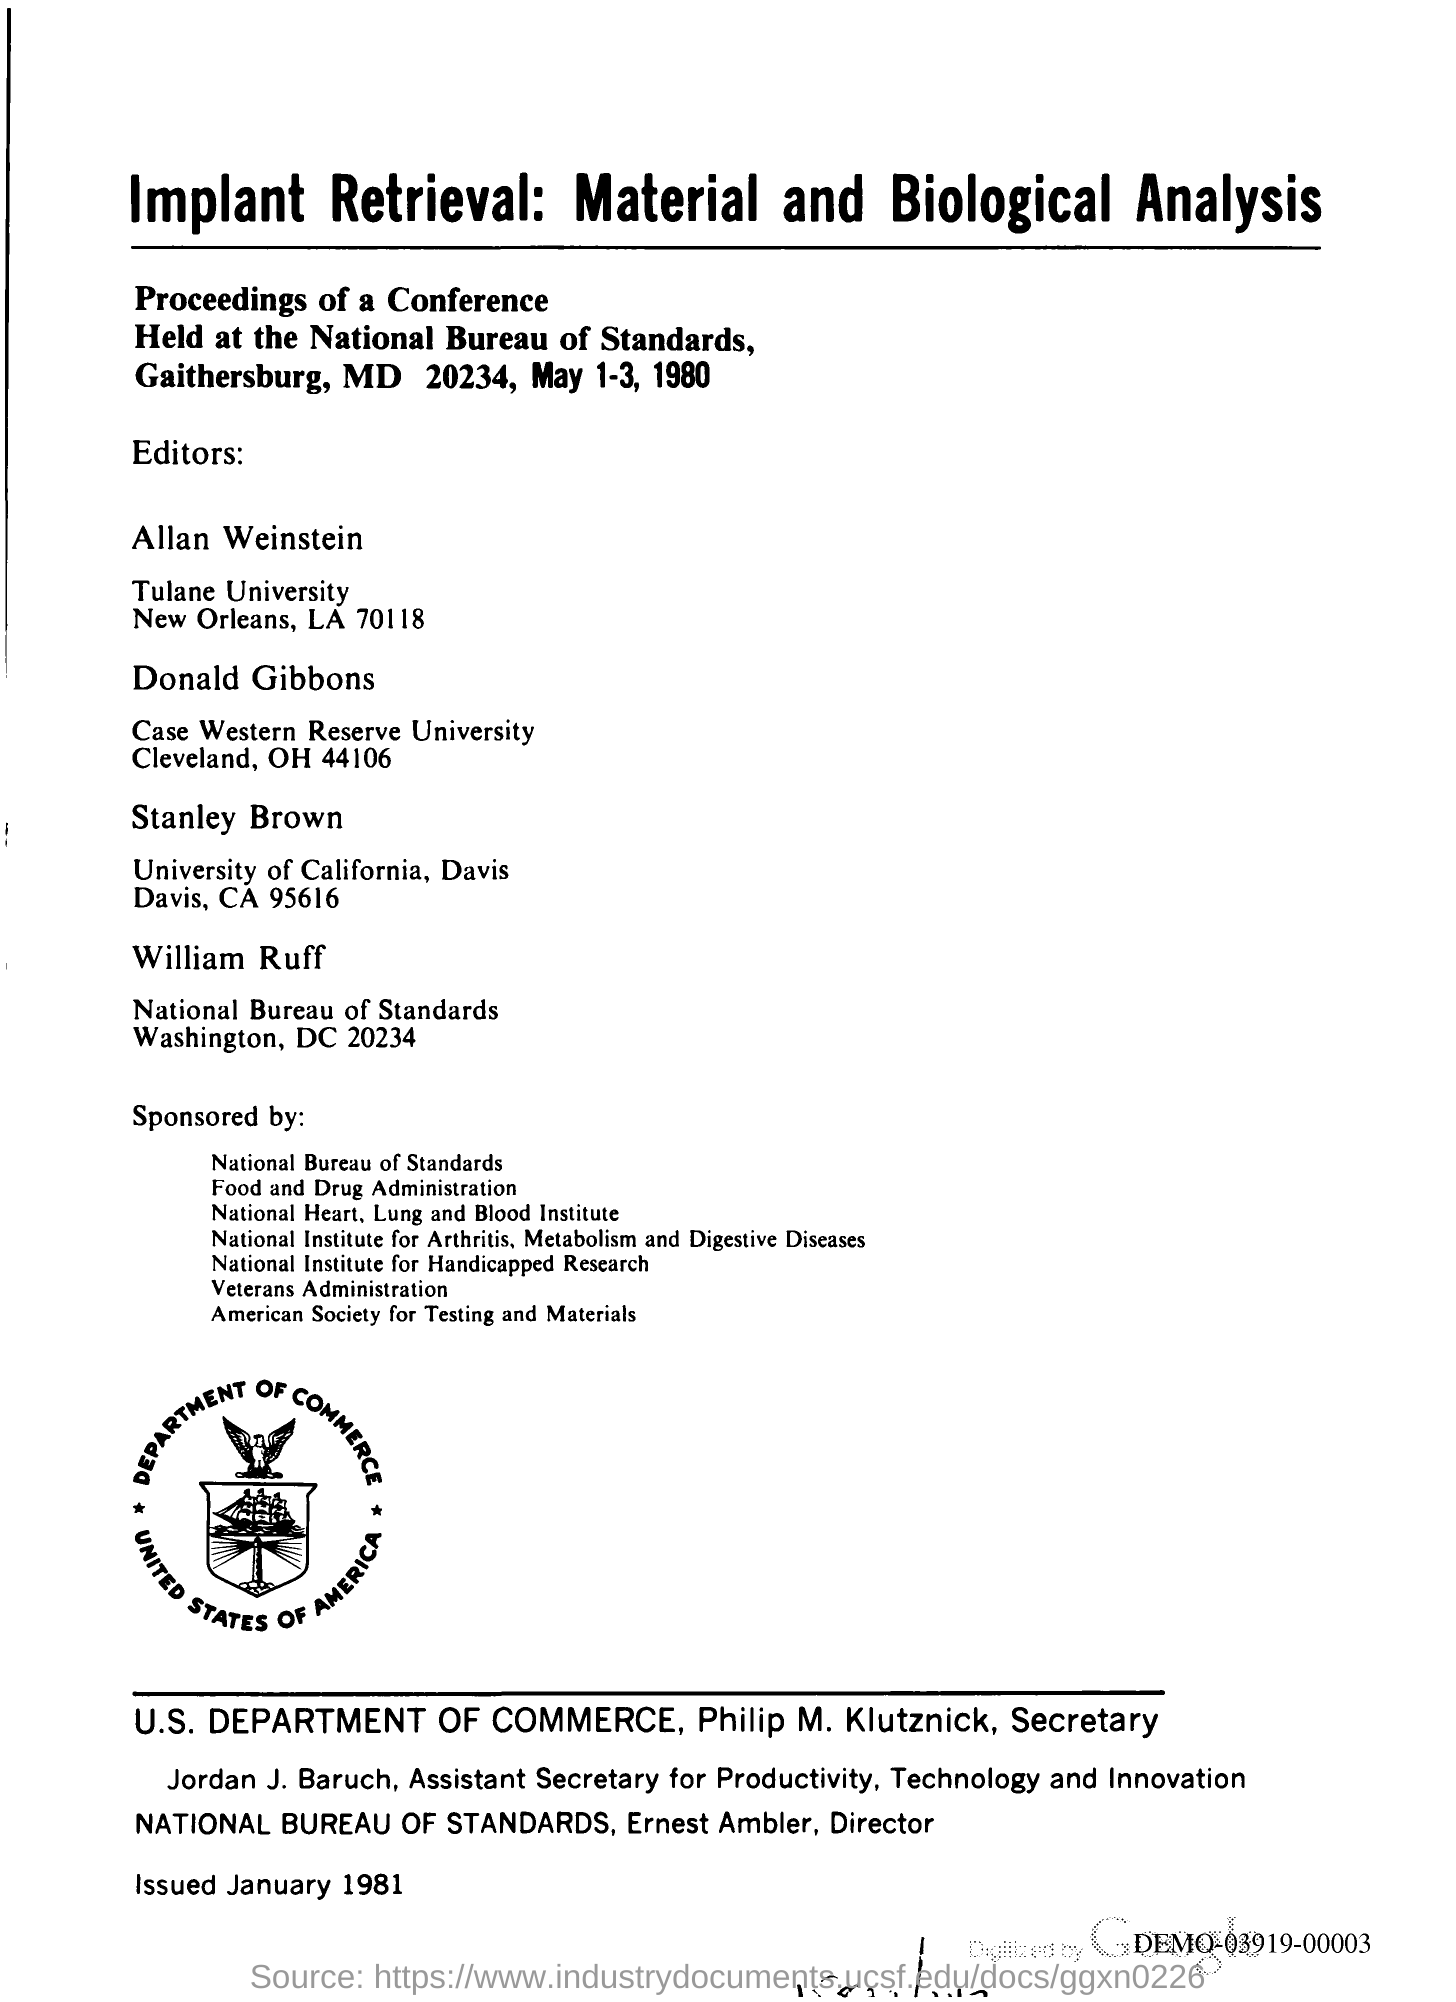Identify some key points in this picture. The conference was held in Gaithersburg. 